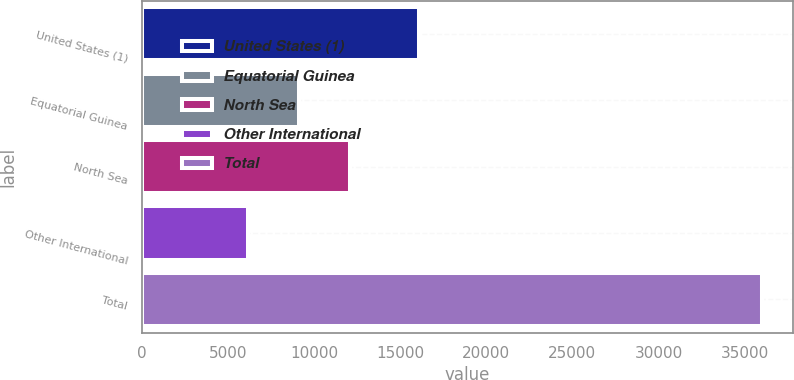Convert chart. <chart><loc_0><loc_0><loc_500><loc_500><bar_chart><fcel>United States (1)<fcel>Equatorial Guinea<fcel>North Sea<fcel>Other International<fcel>Total<nl><fcel>16084<fcel>9128.3<fcel>12115.6<fcel>6141<fcel>36014<nl></chart> 